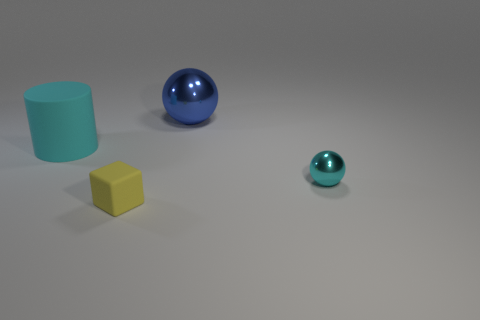Add 1 large gray metal spheres. How many objects exist? 5 Subtract all cylinders. How many objects are left? 3 Add 3 large blue objects. How many large blue objects exist? 4 Subtract 1 blue balls. How many objects are left? 3 Subtract all blue cylinders. Subtract all gray balls. How many cylinders are left? 1 Subtract all small yellow cubes. Subtract all shiny balls. How many objects are left? 1 Add 3 cyan metallic things. How many cyan metallic things are left? 4 